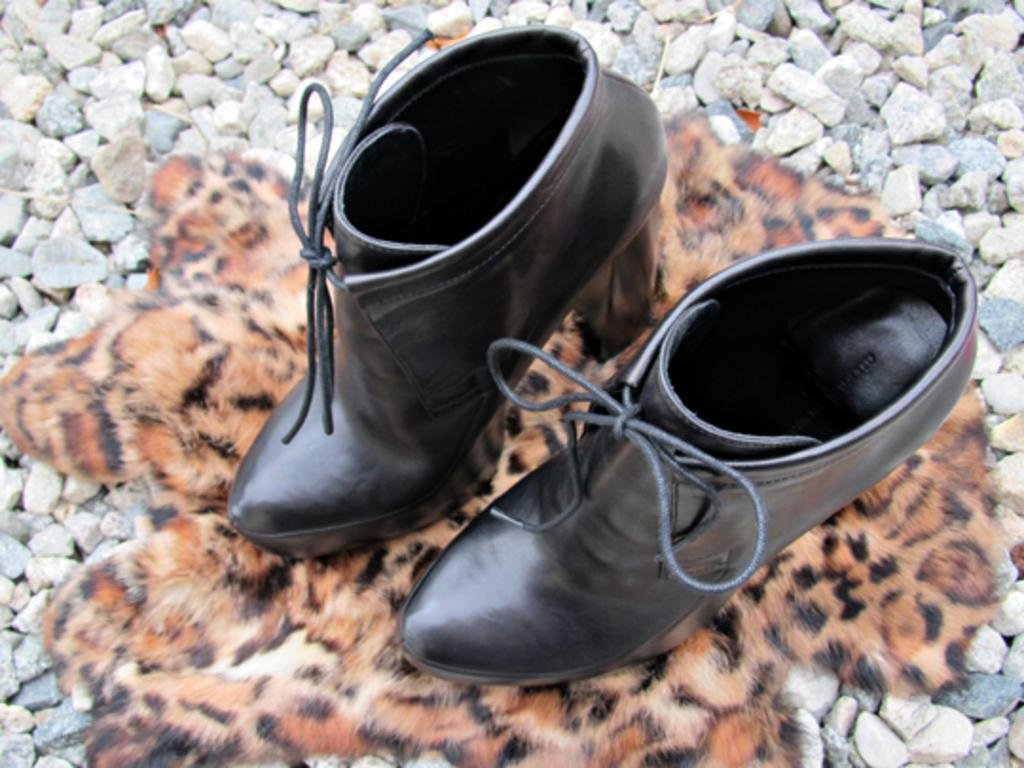What type of footwear is visible in the image? There are shoes in the image. Can you describe the setting in which the shoes are placed? There is a tiger sink on stones in the image. What type of thunder can be heard in the image? There is no thunder present in the image, as it is a visual medium and does not contain sound. 